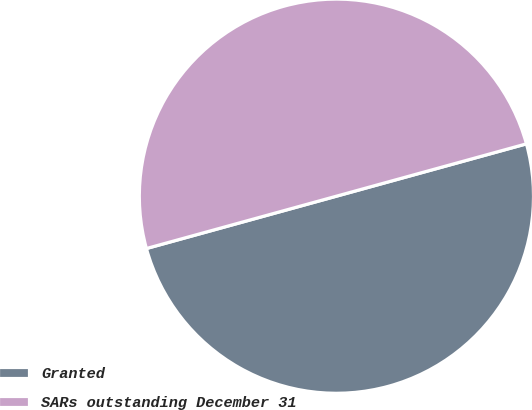<chart> <loc_0><loc_0><loc_500><loc_500><pie_chart><fcel>Granted<fcel>SARs outstanding December 31<nl><fcel>50.0%<fcel>50.0%<nl></chart> 